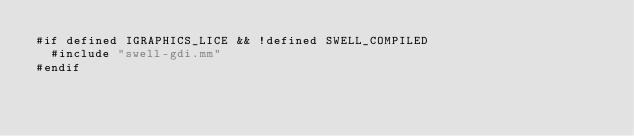<code> <loc_0><loc_0><loc_500><loc_500><_ObjectiveC_>#if defined IGRAPHICS_LICE && !defined SWELL_COMPILED
  #include "swell-gdi.mm"
#endif
</code> 